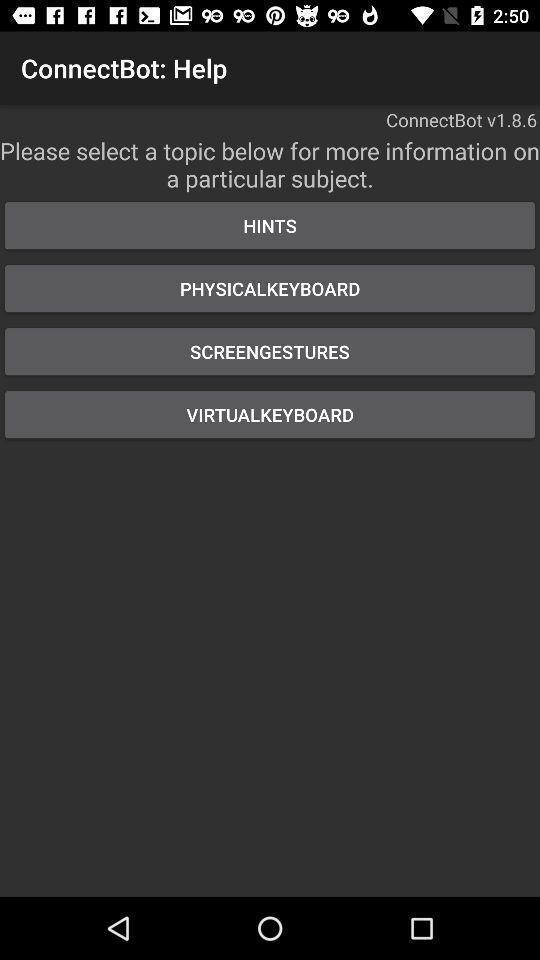Summarize the information in this screenshot. Page showing list of different topics. 